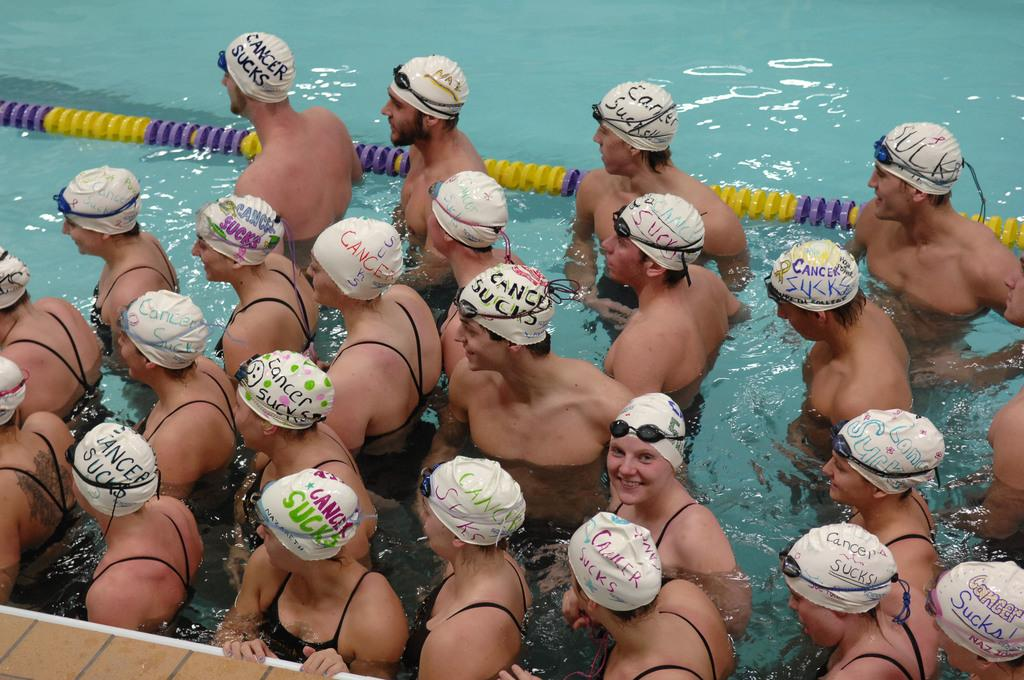What are the persons in the image doing? The persons in the water are likely swimming or engaging in water activities. What protective gear are the persons wearing? The persons are wearing caps and goggles. What can be seen at the left bottom of the image? There is a floor at the left bottom of the image. What is present on the water behind the persons? There is a rope on the water behind the persons. What type of rod is being used by the persons in the image? There is no rod visible in the image; the persons are wearing caps and goggles and are in the water. 